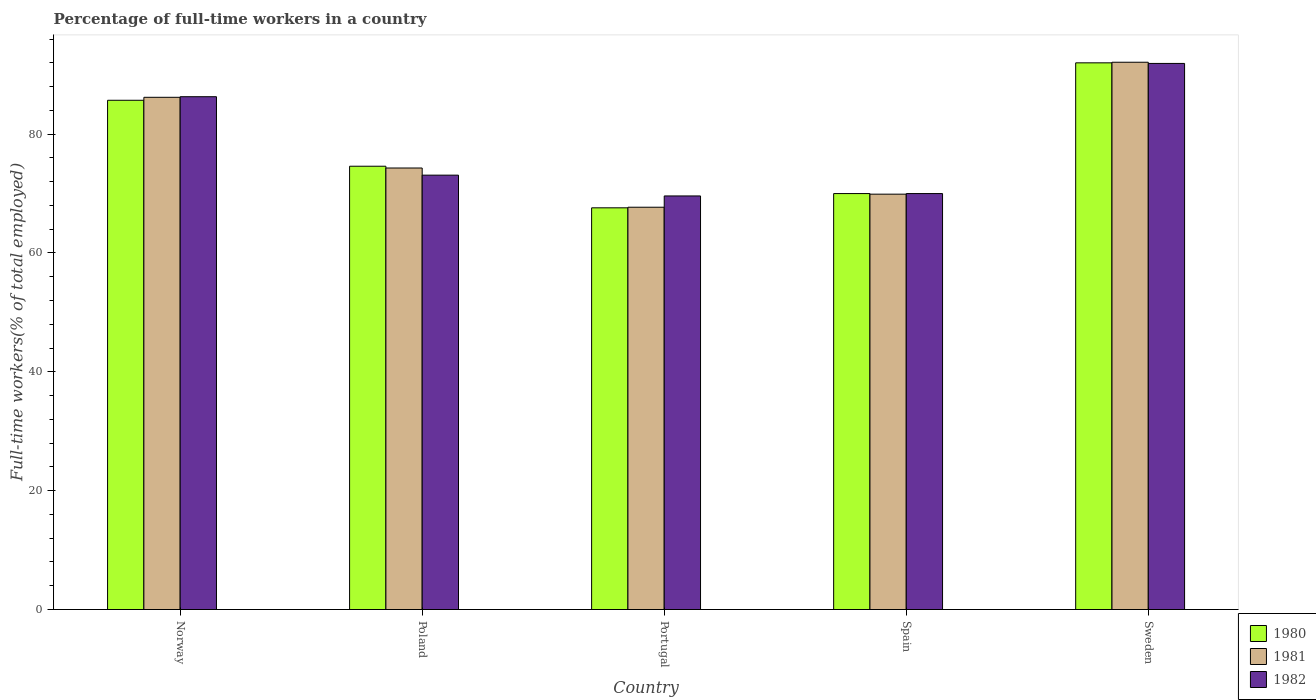How many different coloured bars are there?
Provide a short and direct response. 3. How many groups of bars are there?
Make the answer very short. 5. How many bars are there on the 2nd tick from the right?
Your response must be concise. 3. In how many cases, is the number of bars for a given country not equal to the number of legend labels?
Ensure brevity in your answer.  0. What is the percentage of full-time workers in 1980 in Norway?
Provide a succinct answer. 85.7. Across all countries, what is the maximum percentage of full-time workers in 1980?
Ensure brevity in your answer.  92. Across all countries, what is the minimum percentage of full-time workers in 1982?
Offer a very short reply. 69.6. What is the total percentage of full-time workers in 1981 in the graph?
Provide a short and direct response. 390.2. What is the difference between the percentage of full-time workers in 1982 in Norway and that in Portugal?
Provide a succinct answer. 16.7. What is the difference between the percentage of full-time workers in 1982 in Spain and the percentage of full-time workers in 1980 in Norway?
Give a very brief answer. -15.7. What is the average percentage of full-time workers in 1982 per country?
Offer a terse response. 78.18. What is the difference between the percentage of full-time workers of/in 1980 and percentage of full-time workers of/in 1982 in Norway?
Offer a terse response. -0.6. In how many countries, is the percentage of full-time workers in 1980 greater than 56 %?
Your response must be concise. 5. What is the ratio of the percentage of full-time workers in 1982 in Poland to that in Portugal?
Your answer should be compact. 1.05. Is the percentage of full-time workers in 1981 in Poland less than that in Portugal?
Make the answer very short. No. Is the difference between the percentage of full-time workers in 1980 in Norway and Poland greater than the difference between the percentage of full-time workers in 1982 in Norway and Poland?
Offer a very short reply. No. What is the difference between the highest and the second highest percentage of full-time workers in 1980?
Offer a very short reply. -17.4. What is the difference between the highest and the lowest percentage of full-time workers in 1981?
Ensure brevity in your answer.  24.4. Is it the case that in every country, the sum of the percentage of full-time workers in 1981 and percentage of full-time workers in 1982 is greater than the percentage of full-time workers in 1980?
Your answer should be compact. Yes. How many bars are there?
Your answer should be very brief. 15. Are the values on the major ticks of Y-axis written in scientific E-notation?
Keep it short and to the point. No. Where does the legend appear in the graph?
Keep it short and to the point. Bottom right. What is the title of the graph?
Your answer should be very brief. Percentage of full-time workers in a country. Does "2008" appear as one of the legend labels in the graph?
Your answer should be very brief. No. What is the label or title of the Y-axis?
Make the answer very short. Full-time workers(% of total employed). What is the Full-time workers(% of total employed) of 1980 in Norway?
Provide a short and direct response. 85.7. What is the Full-time workers(% of total employed) in 1981 in Norway?
Your answer should be very brief. 86.2. What is the Full-time workers(% of total employed) in 1982 in Norway?
Offer a terse response. 86.3. What is the Full-time workers(% of total employed) in 1980 in Poland?
Your response must be concise. 74.6. What is the Full-time workers(% of total employed) of 1981 in Poland?
Provide a short and direct response. 74.3. What is the Full-time workers(% of total employed) in 1982 in Poland?
Ensure brevity in your answer.  73.1. What is the Full-time workers(% of total employed) of 1980 in Portugal?
Provide a short and direct response. 67.6. What is the Full-time workers(% of total employed) in 1981 in Portugal?
Provide a succinct answer. 67.7. What is the Full-time workers(% of total employed) in 1982 in Portugal?
Your answer should be very brief. 69.6. What is the Full-time workers(% of total employed) of 1980 in Spain?
Offer a terse response. 70. What is the Full-time workers(% of total employed) of 1981 in Spain?
Keep it short and to the point. 69.9. What is the Full-time workers(% of total employed) in 1980 in Sweden?
Your response must be concise. 92. What is the Full-time workers(% of total employed) of 1981 in Sweden?
Your answer should be very brief. 92.1. What is the Full-time workers(% of total employed) of 1982 in Sweden?
Offer a terse response. 91.9. Across all countries, what is the maximum Full-time workers(% of total employed) in 1980?
Your response must be concise. 92. Across all countries, what is the maximum Full-time workers(% of total employed) in 1981?
Provide a succinct answer. 92.1. Across all countries, what is the maximum Full-time workers(% of total employed) in 1982?
Provide a short and direct response. 91.9. Across all countries, what is the minimum Full-time workers(% of total employed) in 1980?
Offer a very short reply. 67.6. Across all countries, what is the minimum Full-time workers(% of total employed) in 1981?
Your response must be concise. 67.7. Across all countries, what is the minimum Full-time workers(% of total employed) in 1982?
Ensure brevity in your answer.  69.6. What is the total Full-time workers(% of total employed) in 1980 in the graph?
Give a very brief answer. 389.9. What is the total Full-time workers(% of total employed) of 1981 in the graph?
Provide a short and direct response. 390.2. What is the total Full-time workers(% of total employed) of 1982 in the graph?
Ensure brevity in your answer.  390.9. What is the difference between the Full-time workers(% of total employed) in 1981 in Norway and that in Spain?
Your answer should be compact. 16.3. What is the difference between the Full-time workers(% of total employed) in 1982 in Norway and that in Spain?
Provide a short and direct response. 16.3. What is the difference between the Full-time workers(% of total employed) of 1981 in Poland and that in Portugal?
Keep it short and to the point. 6.6. What is the difference between the Full-time workers(% of total employed) in 1982 in Poland and that in Portugal?
Give a very brief answer. 3.5. What is the difference between the Full-time workers(% of total employed) in 1980 in Poland and that in Spain?
Provide a succinct answer. 4.6. What is the difference between the Full-time workers(% of total employed) of 1982 in Poland and that in Spain?
Provide a short and direct response. 3.1. What is the difference between the Full-time workers(% of total employed) of 1980 in Poland and that in Sweden?
Your response must be concise. -17.4. What is the difference between the Full-time workers(% of total employed) of 1981 in Poland and that in Sweden?
Your answer should be very brief. -17.8. What is the difference between the Full-time workers(% of total employed) in 1982 in Poland and that in Sweden?
Offer a terse response. -18.8. What is the difference between the Full-time workers(% of total employed) of 1980 in Portugal and that in Spain?
Your answer should be very brief. -2.4. What is the difference between the Full-time workers(% of total employed) in 1981 in Portugal and that in Spain?
Make the answer very short. -2.2. What is the difference between the Full-time workers(% of total employed) in 1982 in Portugal and that in Spain?
Keep it short and to the point. -0.4. What is the difference between the Full-time workers(% of total employed) of 1980 in Portugal and that in Sweden?
Provide a short and direct response. -24.4. What is the difference between the Full-time workers(% of total employed) in 1981 in Portugal and that in Sweden?
Make the answer very short. -24.4. What is the difference between the Full-time workers(% of total employed) in 1982 in Portugal and that in Sweden?
Your answer should be compact. -22.3. What is the difference between the Full-time workers(% of total employed) in 1981 in Spain and that in Sweden?
Keep it short and to the point. -22.2. What is the difference between the Full-time workers(% of total employed) in 1982 in Spain and that in Sweden?
Your answer should be very brief. -21.9. What is the difference between the Full-time workers(% of total employed) of 1980 in Norway and the Full-time workers(% of total employed) of 1981 in Portugal?
Give a very brief answer. 18. What is the difference between the Full-time workers(% of total employed) in 1980 in Norway and the Full-time workers(% of total employed) in 1982 in Portugal?
Keep it short and to the point. 16.1. What is the difference between the Full-time workers(% of total employed) of 1981 in Norway and the Full-time workers(% of total employed) of 1982 in Portugal?
Provide a succinct answer. 16.6. What is the difference between the Full-time workers(% of total employed) in 1980 in Norway and the Full-time workers(% of total employed) in 1981 in Spain?
Your answer should be compact. 15.8. What is the difference between the Full-time workers(% of total employed) in 1980 in Norway and the Full-time workers(% of total employed) in 1982 in Sweden?
Keep it short and to the point. -6.2. What is the difference between the Full-time workers(% of total employed) of 1981 in Norway and the Full-time workers(% of total employed) of 1982 in Sweden?
Give a very brief answer. -5.7. What is the difference between the Full-time workers(% of total employed) of 1980 in Poland and the Full-time workers(% of total employed) of 1981 in Portugal?
Give a very brief answer. 6.9. What is the difference between the Full-time workers(% of total employed) in 1981 in Poland and the Full-time workers(% of total employed) in 1982 in Portugal?
Keep it short and to the point. 4.7. What is the difference between the Full-time workers(% of total employed) in 1980 in Poland and the Full-time workers(% of total employed) in 1982 in Spain?
Your answer should be compact. 4.6. What is the difference between the Full-time workers(% of total employed) in 1980 in Poland and the Full-time workers(% of total employed) in 1981 in Sweden?
Ensure brevity in your answer.  -17.5. What is the difference between the Full-time workers(% of total employed) in 1980 in Poland and the Full-time workers(% of total employed) in 1982 in Sweden?
Offer a terse response. -17.3. What is the difference between the Full-time workers(% of total employed) of 1981 in Poland and the Full-time workers(% of total employed) of 1982 in Sweden?
Offer a terse response. -17.6. What is the difference between the Full-time workers(% of total employed) in 1981 in Portugal and the Full-time workers(% of total employed) in 1982 in Spain?
Offer a very short reply. -2.3. What is the difference between the Full-time workers(% of total employed) of 1980 in Portugal and the Full-time workers(% of total employed) of 1981 in Sweden?
Provide a succinct answer. -24.5. What is the difference between the Full-time workers(% of total employed) in 1980 in Portugal and the Full-time workers(% of total employed) in 1982 in Sweden?
Your response must be concise. -24.3. What is the difference between the Full-time workers(% of total employed) in 1981 in Portugal and the Full-time workers(% of total employed) in 1982 in Sweden?
Your answer should be very brief. -24.2. What is the difference between the Full-time workers(% of total employed) of 1980 in Spain and the Full-time workers(% of total employed) of 1981 in Sweden?
Your answer should be very brief. -22.1. What is the difference between the Full-time workers(% of total employed) of 1980 in Spain and the Full-time workers(% of total employed) of 1982 in Sweden?
Offer a very short reply. -21.9. What is the average Full-time workers(% of total employed) of 1980 per country?
Give a very brief answer. 77.98. What is the average Full-time workers(% of total employed) in 1981 per country?
Your response must be concise. 78.04. What is the average Full-time workers(% of total employed) in 1982 per country?
Give a very brief answer. 78.18. What is the difference between the Full-time workers(% of total employed) of 1980 and Full-time workers(% of total employed) of 1981 in Norway?
Offer a very short reply. -0.5. What is the difference between the Full-time workers(% of total employed) of 1980 and Full-time workers(% of total employed) of 1982 in Poland?
Make the answer very short. 1.5. What is the difference between the Full-time workers(% of total employed) of 1980 and Full-time workers(% of total employed) of 1982 in Portugal?
Make the answer very short. -2. What is the difference between the Full-time workers(% of total employed) of 1980 and Full-time workers(% of total employed) of 1981 in Spain?
Offer a terse response. 0.1. What is the difference between the Full-time workers(% of total employed) in 1981 and Full-time workers(% of total employed) in 1982 in Spain?
Make the answer very short. -0.1. What is the difference between the Full-time workers(% of total employed) of 1980 and Full-time workers(% of total employed) of 1982 in Sweden?
Offer a very short reply. 0.1. What is the difference between the Full-time workers(% of total employed) of 1981 and Full-time workers(% of total employed) of 1982 in Sweden?
Your response must be concise. 0.2. What is the ratio of the Full-time workers(% of total employed) of 1980 in Norway to that in Poland?
Give a very brief answer. 1.15. What is the ratio of the Full-time workers(% of total employed) of 1981 in Norway to that in Poland?
Offer a terse response. 1.16. What is the ratio of the Full-time workers(% of total employed) in 1982 in Norway to that in Poland?
Provide a short and direct response. 1.18. What is the ratio of the Full-time workers(% of total employed) of 1980 in Norway to that in Portugal?
Make the answer very short. 1.27. What is the ratio of the Full-time workers(% of total employed) in 1981 in Norway to that in Portugal?
Keep it short and to the point. 1.27. What is the ratio of the Full-time workers(% of total employed) in 1982 in Norway to that in Portugal?
Give a very brief answer. 1.24. What is the ratio of the Full-time workers(% of total employed) in 1980 in Norway to that in Spain?
Your answer should be compact. 1.22. What is the ratio of the Full-time workers(% of total employed) of 1981 in Norway to that in Spain?
Give a very brief answer. 1.23. What is the ratio of the Full-time workers(% of total employed) of 1982 in Norway to that in Spain?
Give a very brief answer. 1.23. What is the ratio of the Full-time workers(% of total employed) of 1980 in Norway to that in Sweden?
Ensure brevity in your answer.  0.93. What is the ratio of the Full-time workers(% of total employed) in 1981 in Norway to that in Sweden?
Make the answer very short. 0.94. What is the ratio of the Full-time workers(% of total employed) of 1982 in Norway to that in Sweden?
Your answer should be very brief. 0.94. What is the ratio of the Full-time workers(% of total employed) of 1980 in Poland to that in Portugal?
Offer a terse response. 1.1. What is the ratio of the Full-time workers(% of total employed) of 1981 in Poland to that in Portugal?
Your response must be concise. 1.1. What is the ratio of the Full-time workers(% of total employed) in 1982 in Poland to that in Portugal?
Provide a short and direct response. 1.05. What is the ratio of the Full-time workers(% of total employed) in 1980 in Poland to that in Spain?
Your answer should be compact. 1.07. What is the ratio of the Full-time workers(% of total employed) of 1981 in Poland to that in Spain?
Offer a very short reply. 1.06. What is the ratio of the Full-time workers(% of total employed) of 1982 in Poland to that in Spain?
Your answer should be very brief. 1.04. What is the ratio of the Full-time workers(% of total employed) in 1980 in Poland to that in Sweden?
Make the answer very short. 0.81. What is the ratio of the Full-time workers(% of total employed) in 1981 in Poland to that in Sweden?
Ensure brevity in your answer.  0.81. What is the ratio of the Full-time workers(% of total employed) in 1982 in Poland to that in Sweden?
Ensure brevity in your answer.  0.8. What is the ratio of the Full-time workers(% of total employed) of 1980 in Portugal to that in Spain?
Provide a short and direct response. 0.97. What is the ratio of the Full-time workers(% of total employed) in 1981 in Portugal to that in Spain?
Give a very brief answer. 0.97. What is the ratio of the Full-time workers(% of total employed) in 1982 in Portugal to that in Spain?
Offer a terse response. 0.99. What is the ratio of the Full-time workers(% of total employed) of 1980 in Portugal to that in Sweden?
Your answer should be very brief. 0.73. What is the ratio of the Full-time workers(% of total employed) of 1981 in Portugal to that in Sweden?
Give a very brief answer. 0.74. What is the ratio of the Full-time workers(% of total employed) in 1982 in Portugal to that in Sweden?
Offer a terse response. 0.76. What is the ratio of the Full-time workers(% of total employed) in 1980 in Spain to that in Sweden?
Make the answer very short. 0.76. What is the ratio of the Full-time workers(% of total employed) of 1981 in Spain to that in Sweden?
Make the answer very short. 0.76. What is the ratio of the Full-time workers(% of total employed) of 1982 in Spain to that in Sweden?
Make the answer very short. 0.76. What is the difference between the highest and the lowest Full-time workers(% of total employed) of 1980?
Keep it short and to the point. 24.4. What is the difference between the highest and the lowest Full-time workers(% of total employed) in 1981?
Offer a terse response. 24.4. What is the difference between the highest and the lowest Full-time workers(% of total employed) in 1982?
Your response must be concise. 22.3. 